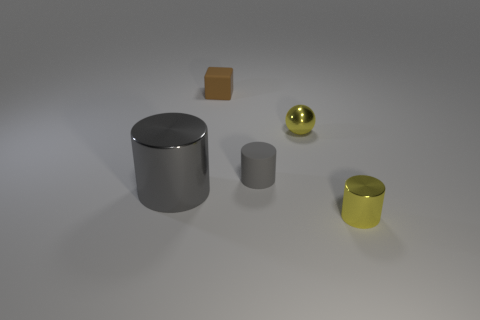If these objects were part of a still life painting, what mood might the artist be conveying? If these objects were depicted in a still life painting, the artist might be aiming to convey a sense of calm and simplicity. The neutral background and orderly arrangement of the geometric shapes can evoke a meditative or contemplative mood, with the subtle interplay of light and reflection adding a serene quality. 